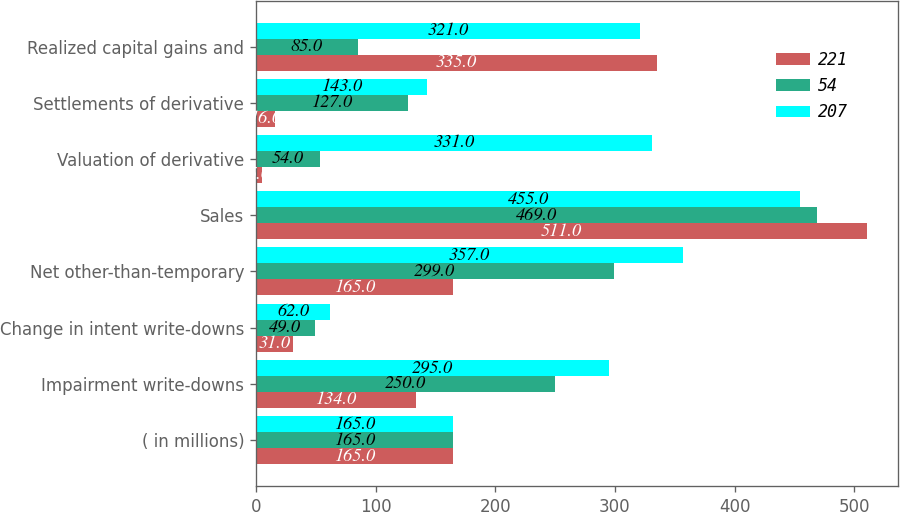<chart> <loc_0><loc_0><loc_500><loc_500><stacked_bar_chart><ecel><fcel>( in millions)<fcel>Impairment write-downs<fcel>Change in intent write-downs<fcel>Net other-than-temporary<fcel>Sales<fcel>Valuation of derivative<fcel>Settlements of derivative<fcel>Realized capital gains and<nl><fcel>221<fcel>165<fcel>134<fcel>31<fcel>165<fcel>511<fcel>5<fcel>16<fcel>335<nl><fcel>54<fcel>165<fcel>250<fcel>49<fcel>299<fcel>469<fcel>54<fcel>127<fcel>85<nl><fcel>207<fcel>165<fcel>295<fcel>62<fcel>357<fcel>455<fcel>331<fcel>143<fcel>321<nl></chart> 